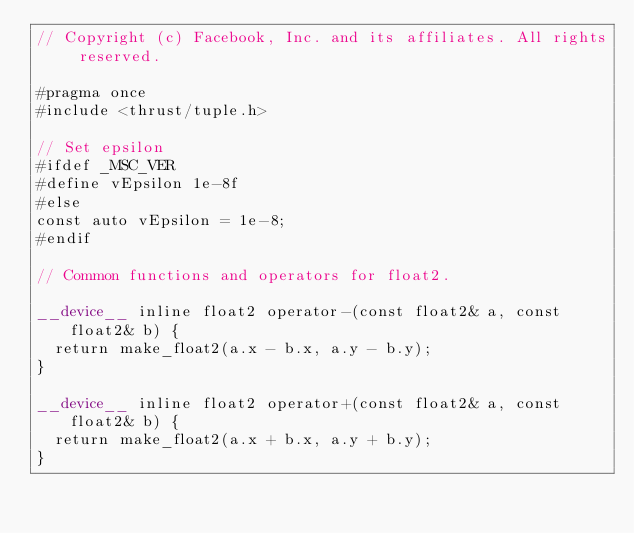<code> <loc_0><loc_0><loc_500><loc_500><_Cuda_>// Copyright (c) Facebook, Inc. and its affiliates. All rights reserved.

#pragma once
#include <thrust/tuple.h>

// Set epsilon
#ifdef _MSC_VER
#define vEpsilon 1e-8f
#else
const auto vEpsilon = 1e-8;
#endif

// Common functions and operators for float2.

__device__ inline float2 operator-(const float2& a, const float2& b) {
  return make_float2(a.x - b.x, a.y - b.y);
}

__device__ inline float2 operator+(const float2& a, const float2& b) {
  return make_float2(a.x + b.x, a.y + b.y);
}
</code> 